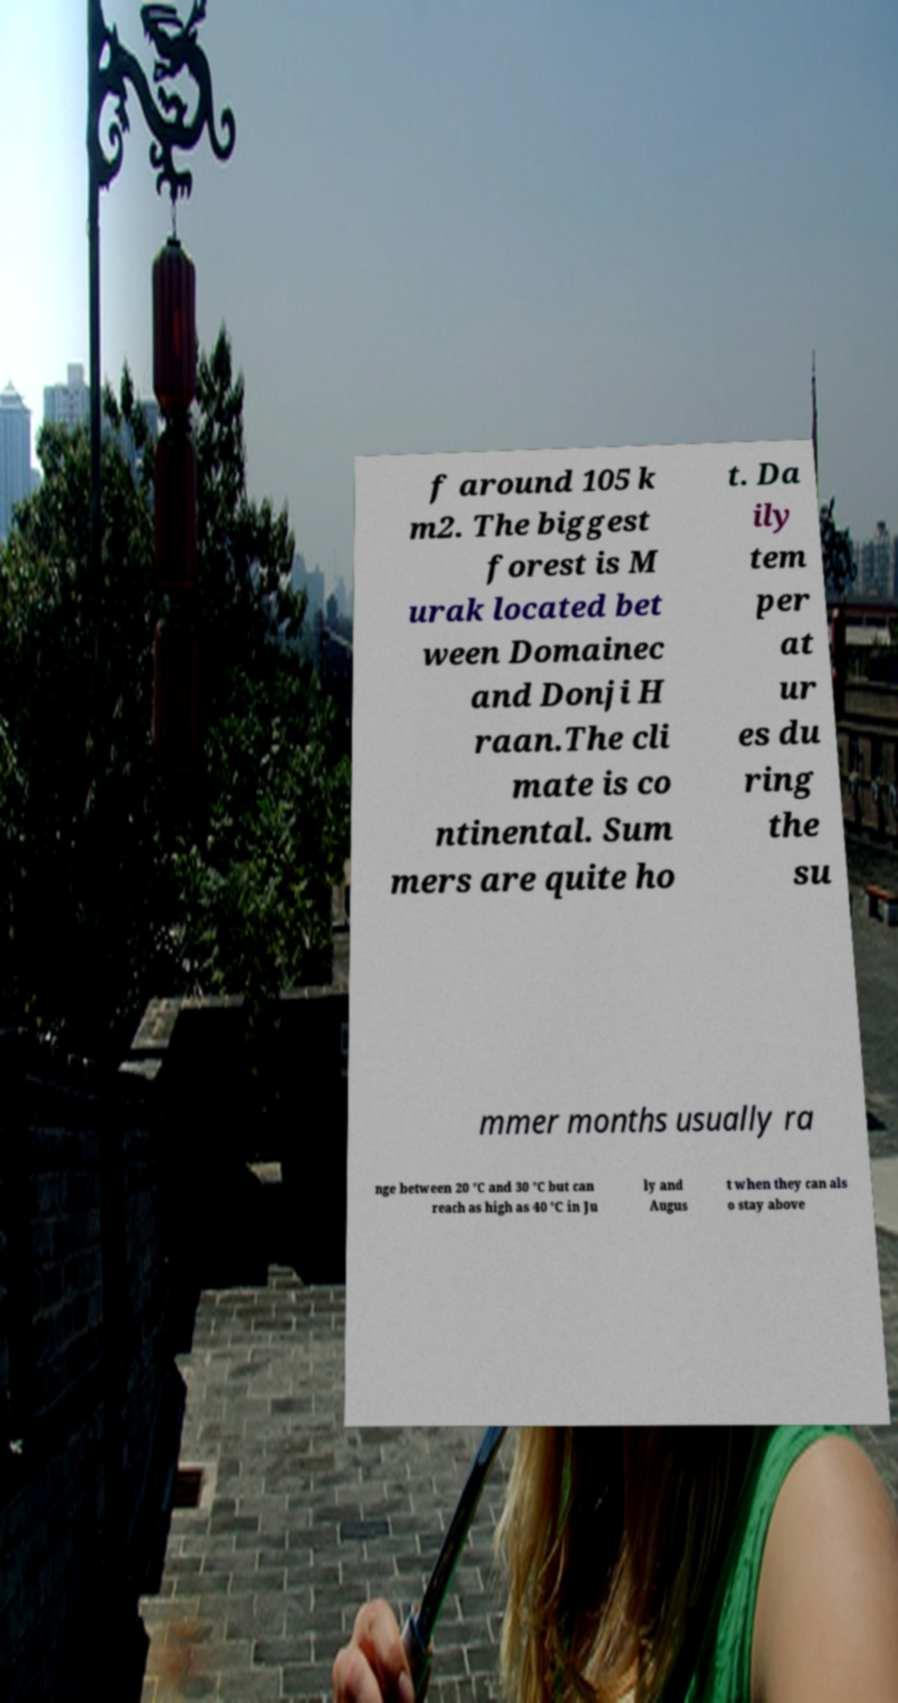I need the written content from this picture converted into text. Can you do that? f around 105 k m2. The biggest forest is M urak located bet ween Domainec and Donji H raan.The cli mate is co ntinental. Sum mers are quite ho t. Da ily tem per at ur es du ring the su mmer months usually ra nge between 20 °C and 30 °C but can reach as high as 40 °C in Ju ly and Augus t when they can als o stay above 